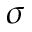<formula> <loc_0><loc_0><loc_500><loc_500>\sigma</formula> 